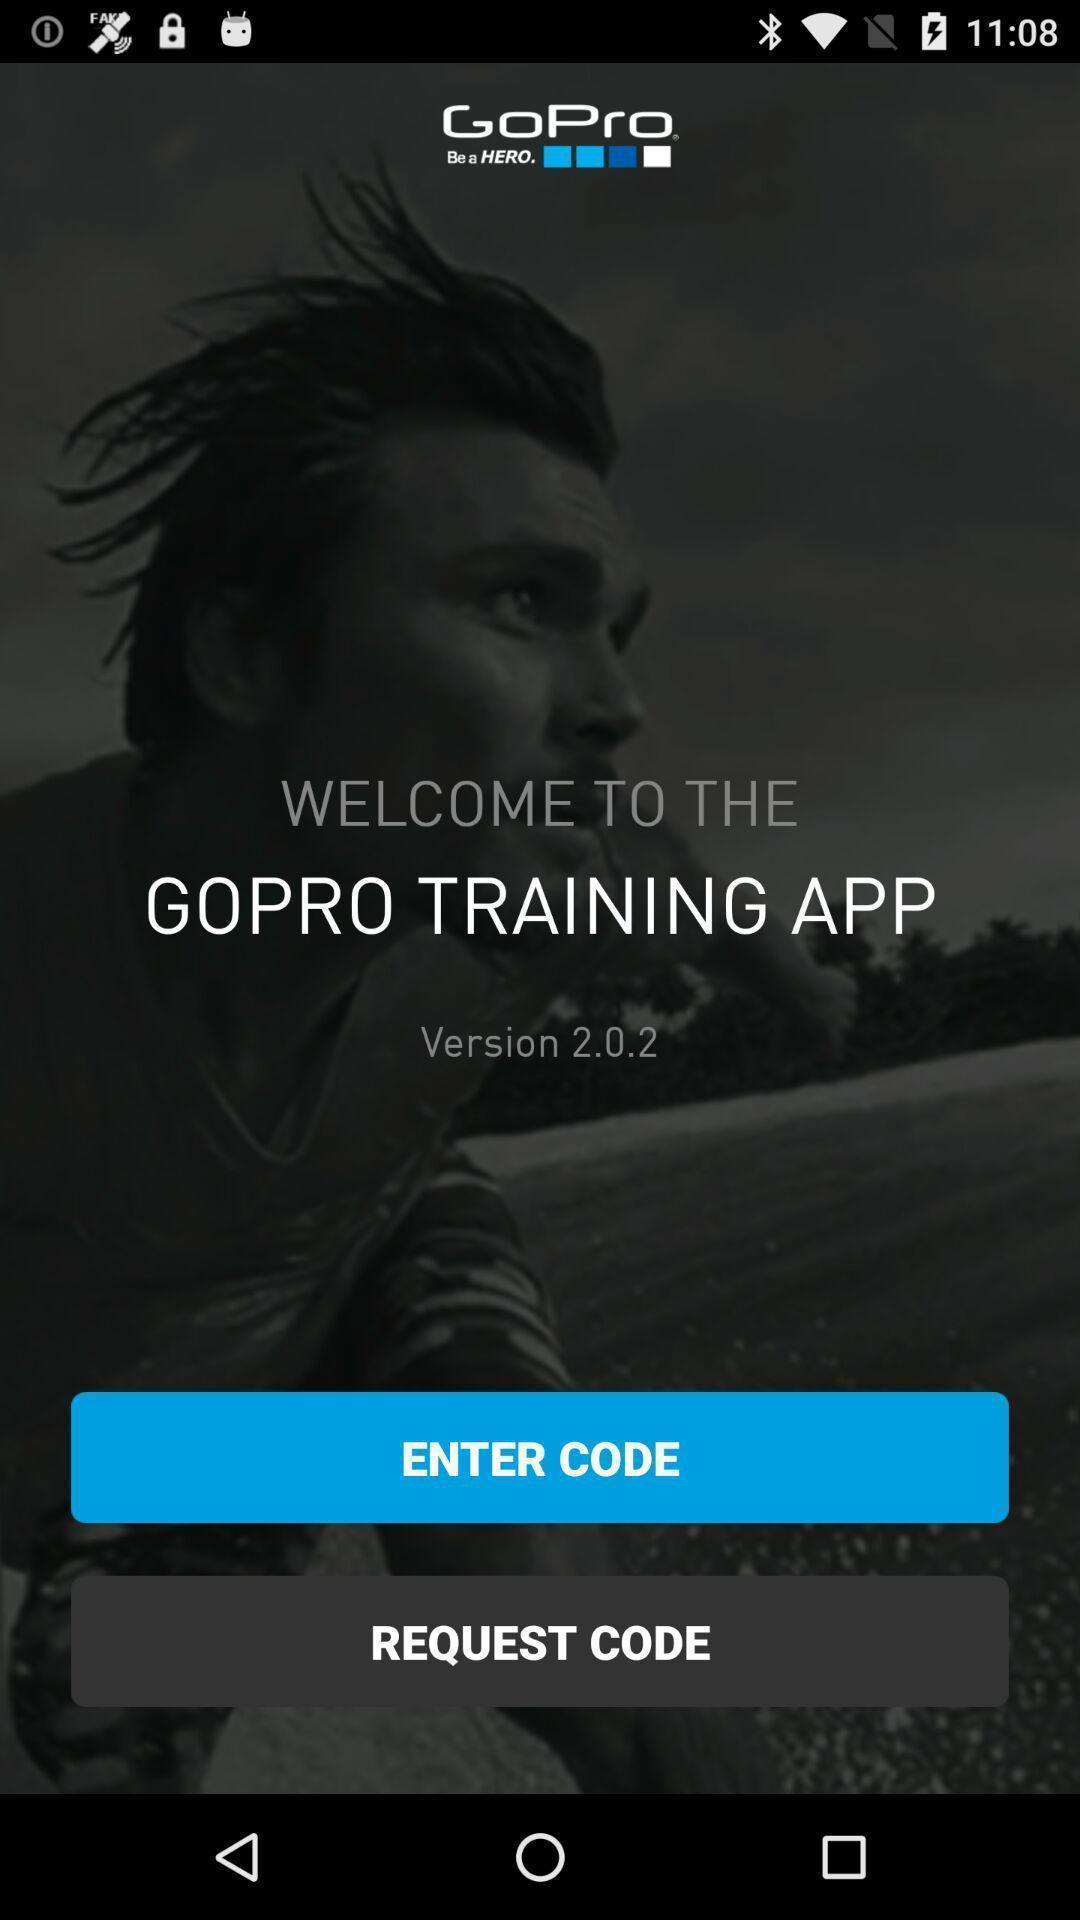Please provide a description for this image. Welcome page with different options. 